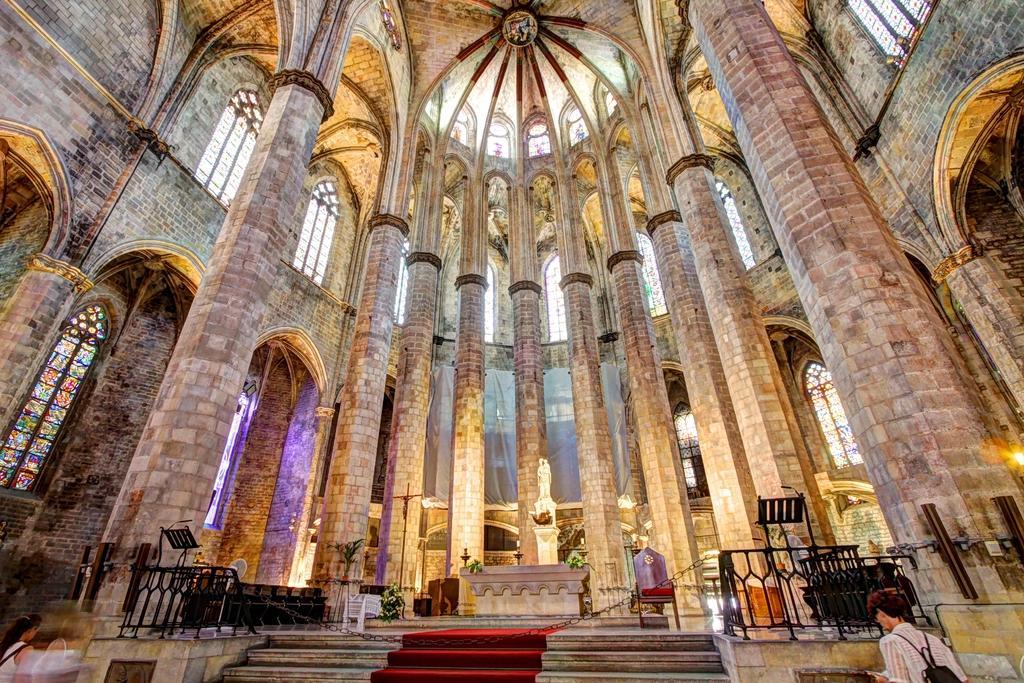Please provide a concise description of this image. There are some pillars in the middle of the image. There are steps at the bottom of the image. There is a person in the bottom left and in the bottom right of the image. 